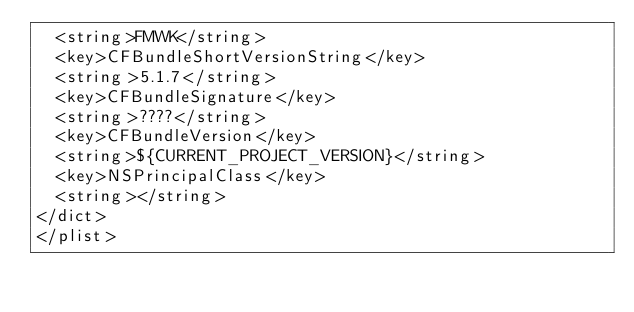<code> <loc_0><loc_0><loc_500><loc_500><_XML_>  <string>FMWK</string>
  <key>CFBundleShortVersionString</key>
  <string>5.1.7</string>
  <key>CFBundleSignature</key>
  <string>????</string>
  <key>CFBundleVersion</key>
  <string>${CURRENT_PROJECT_VERSION}</string>
  <key>NSPrincipalClass</key>
  <string></string>
</dict>
</plist>
</code> 